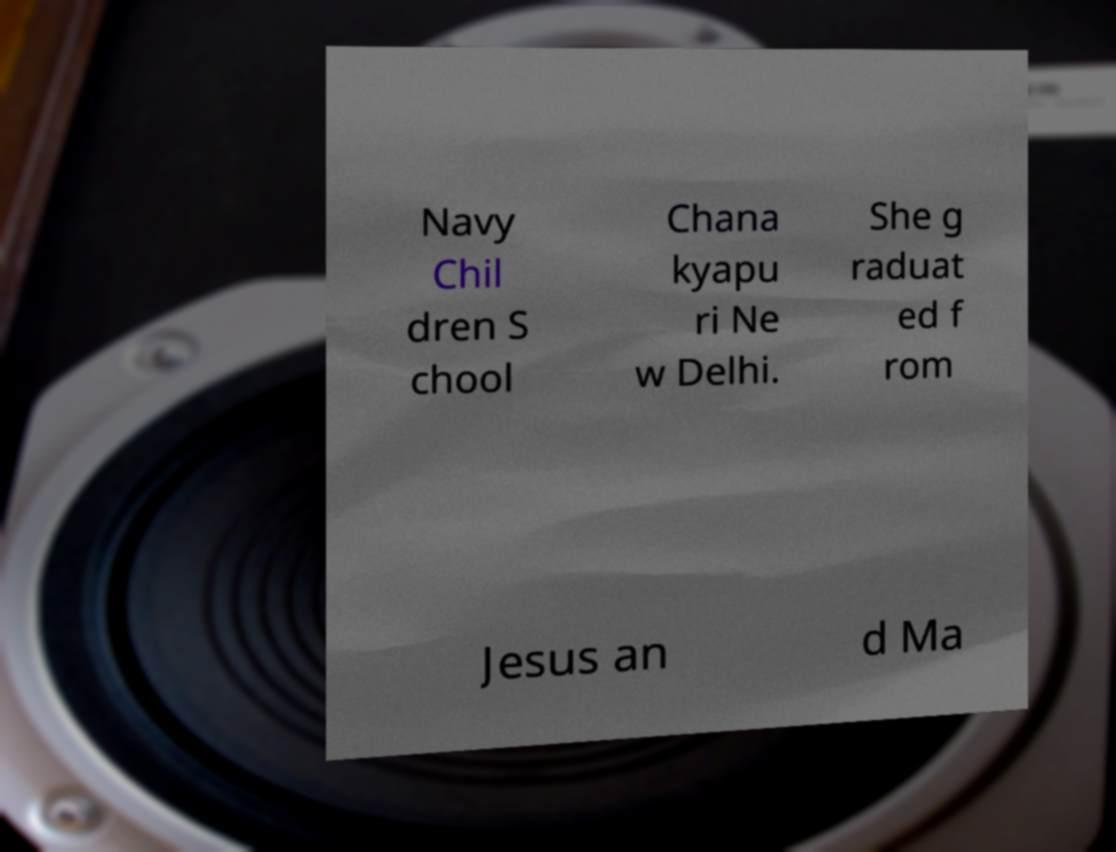I need the written content from this picture converted into text. Can you do that? Navy Chil dren S chool Chana kyapu ri Ne w Delhi. She g raduat ed f rom Jesus an d Ma 